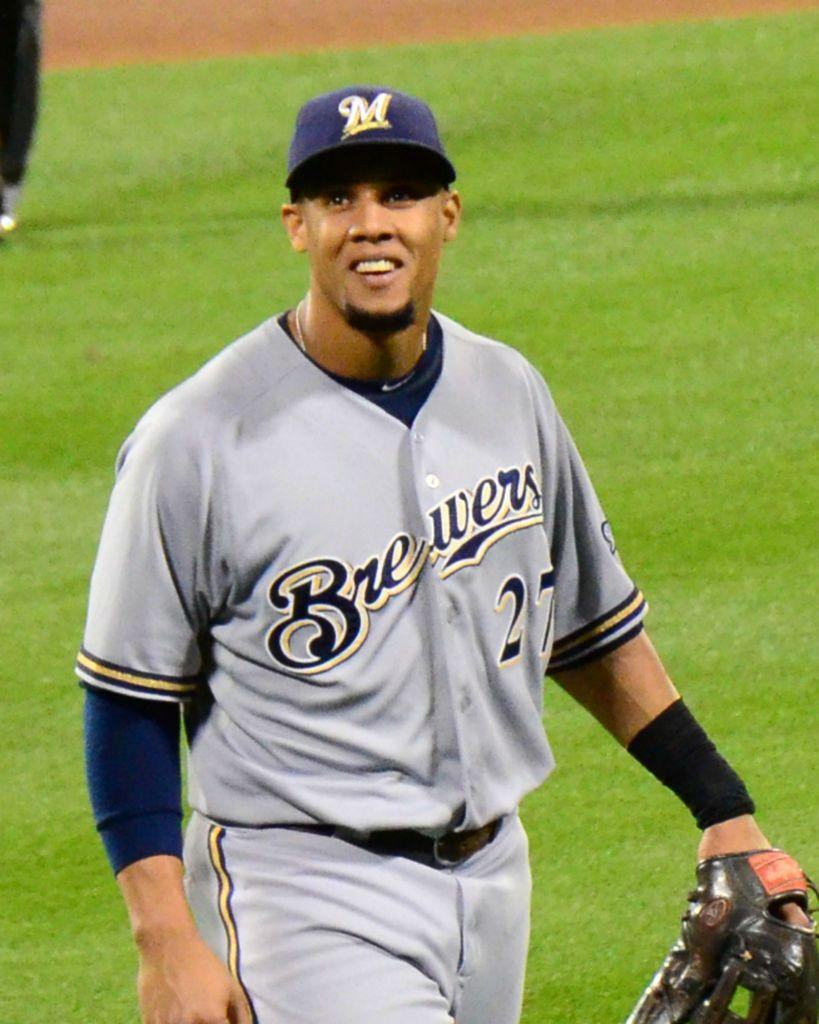<image>
Give a short and clear explanation of the subsequent image. A baseball player with the Brewers is smiling and looking into the distance. 